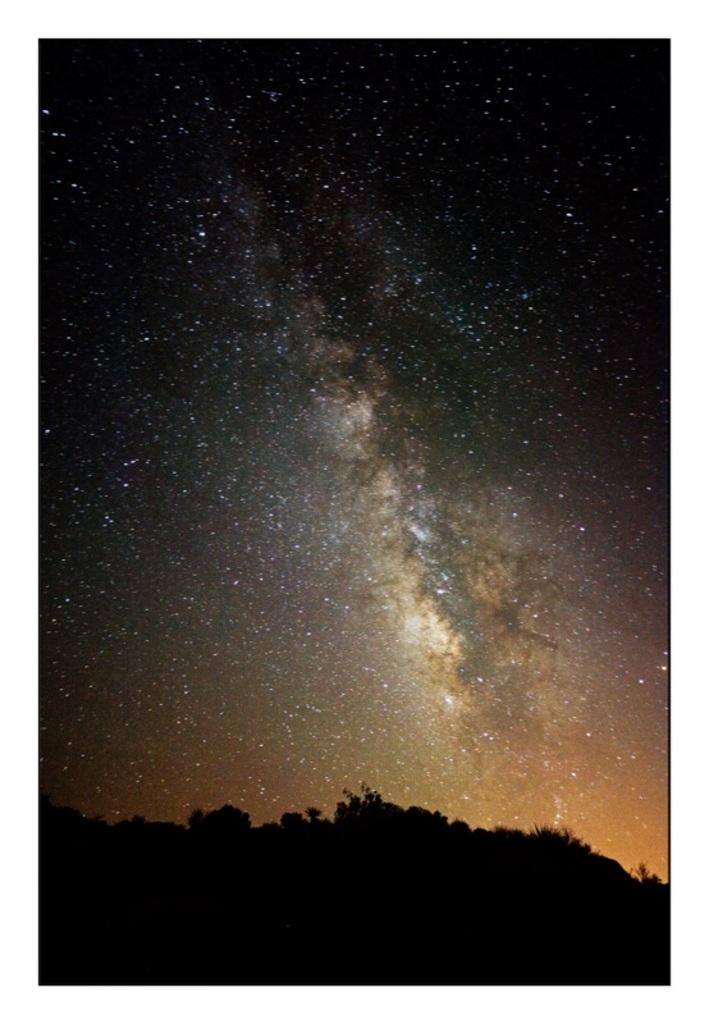What can be seen in the sky in the image? The image depicts a sky with stars. What type of natural vegetation is visible in the image? There are trees visible in the image. What type of territory is being claimed by the beans in the image? There are no beans present in the image, so no territory is being claimed. How many toes can be seen in the image? There are no toes visible in the image. 